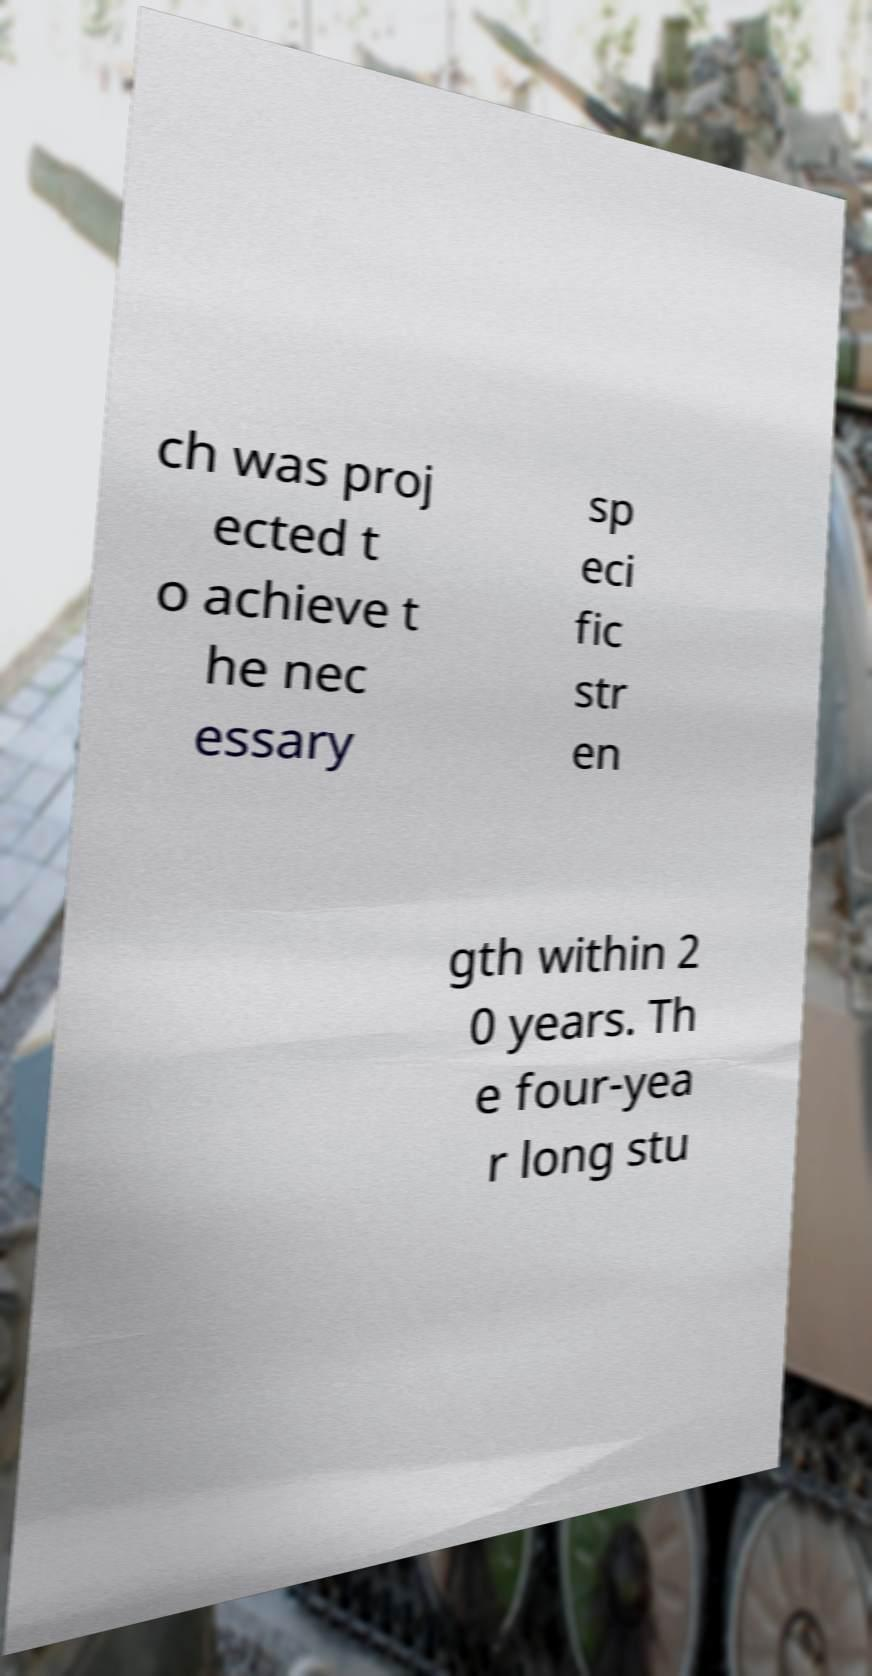Please identify and transcribe the text found in this image. ch was proj ected t o achieve t he nec essary sp eci fic str en gth within 2 0 years. Th e four-yea r long stu 